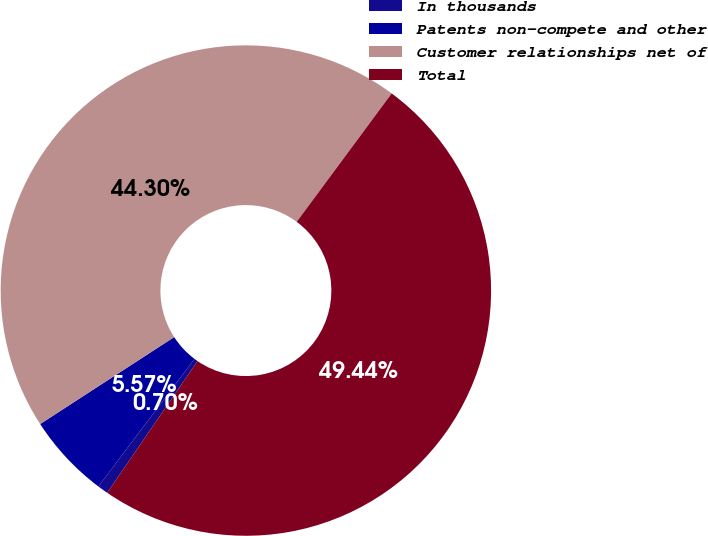Convert chart. <chart><loc_0><loc_0><loc_500><loc_500><pie_chart><fcel>In thousands<fcel>Patents non-compete and other<fcel>Customer relationships net of<fcel>Total<nl><fcel>0.7%<fcel>5.57%<fcel>44.3%<fcel>49.44%<nl></chart> 